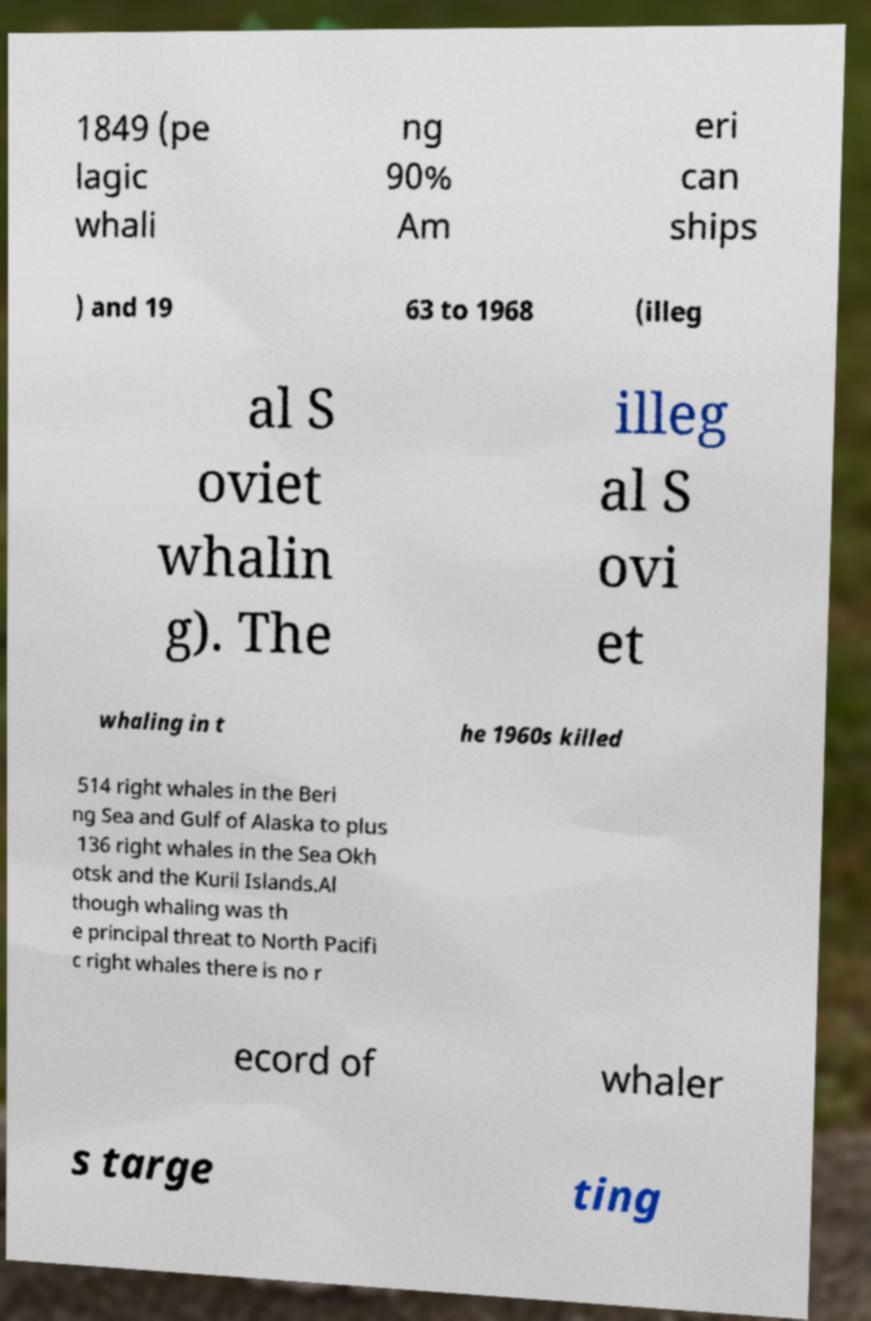Can you read and provide the text displayed in the image?This photo seems to have some interesting text. Can you extract and type it out for me? 1849 (pe lagic whali ng 90% Am eri can ships ) and 19 63 to 1968 (illeg al S oviet whalin g). The illeg al S ovi et whaling in t he 1960s killed 514 right whales in the Beri ng Sea and Gulf of Alaska to plus 136 right whales in the Sea Okh otsk and the Kuril Islands.Al though whaling was th e principal threat to North Pacifi c right whales there is no r ecord of whaler s targe ting 